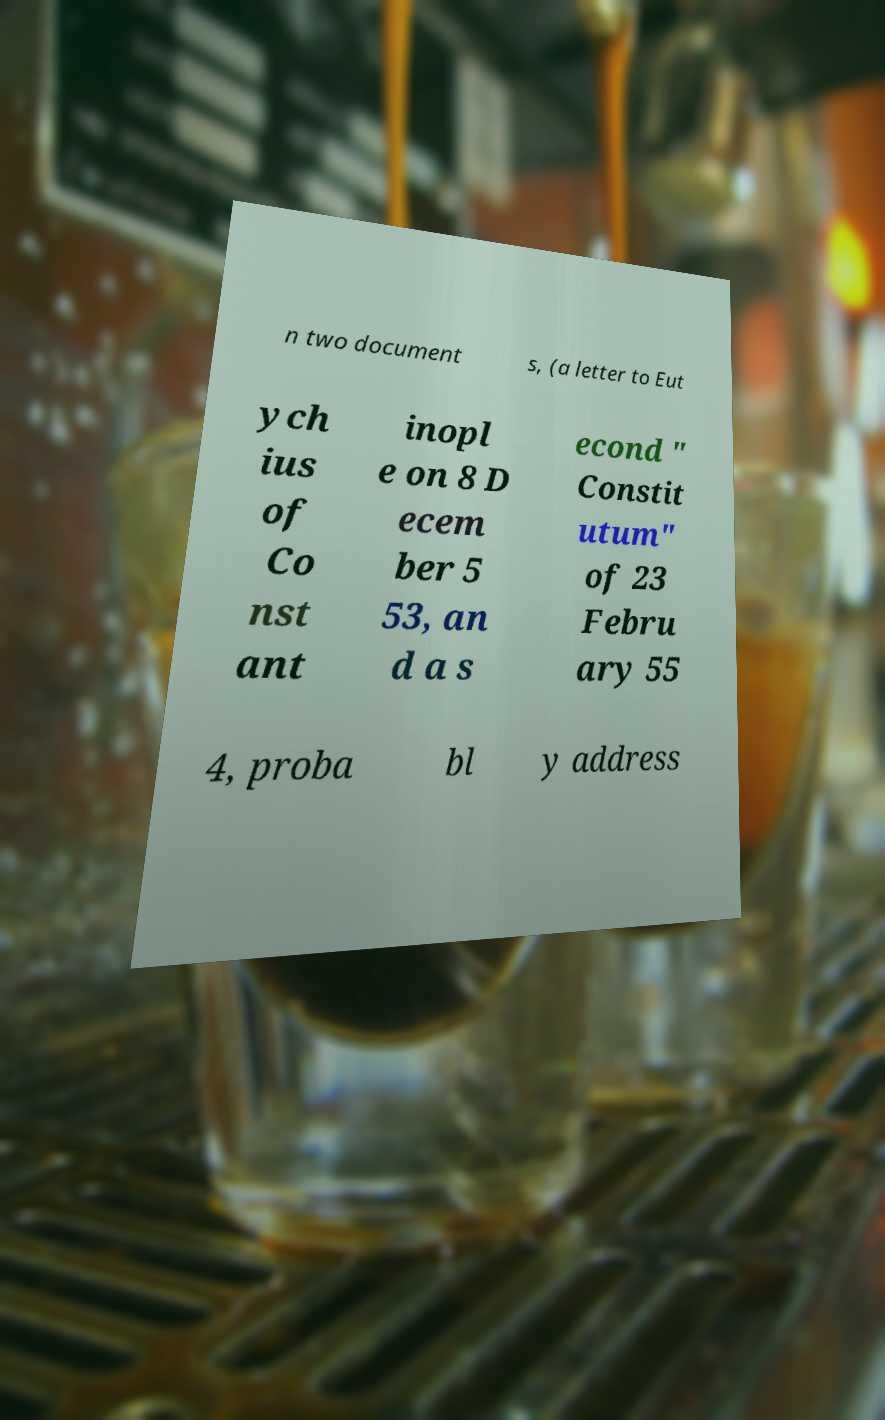For documentation purposes, I need the text within this image transcribed. Could you provide that? n two document s, (a letter to Eut ych ius of Co nst ant inopl e on 8 D ecem ber 5 53, an d a s econd " Constit utum" of 23 Febru ary 55 4, proba bl y address 